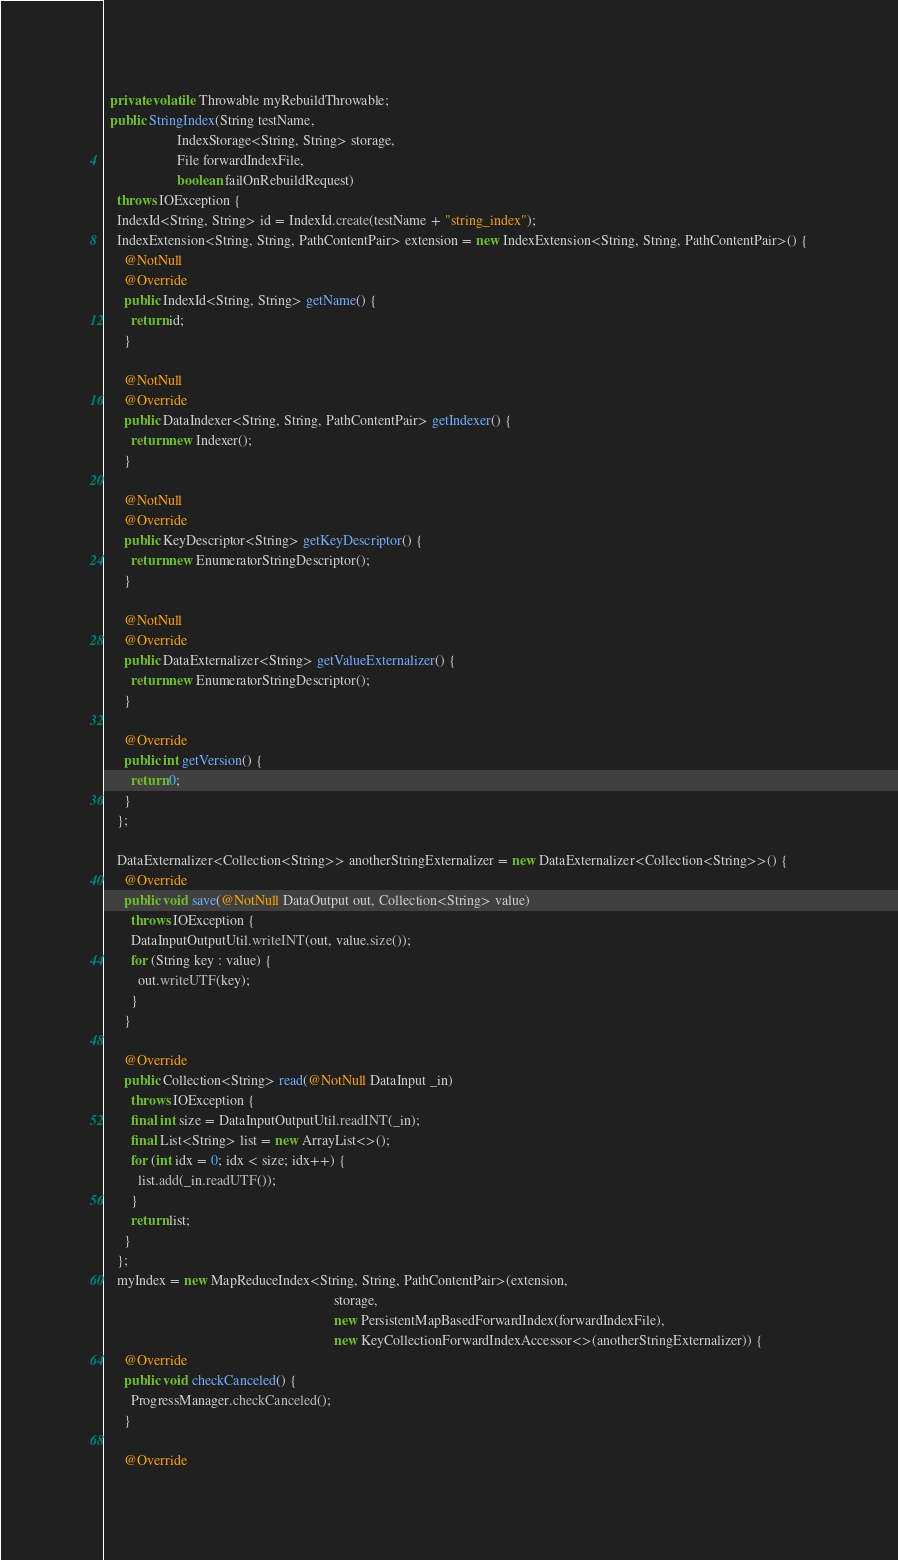<code> <loc_0><loc_0><loc_500><loc_500><_Java_>  private volatile Throwable myRebuildThrowable;
  public StringIndex(String testName,
                     IndexStorage<String, String> storage,
                     File forwardIndexFile,
                     boolean failOnRebuildRequest)
    throws IOException {
    IndexId<String, String> id = IndexId.create(testName + "string_index");
    IndexExtension<String, String, PathContentPair> extension = new IndexExtension<String, String, PathContentPair>() {
      @NotNull
      @Override
      public IndexId<String, String> getName() {
        return id;
      }

      @NotNull
      @Override
      public DataIndexer<String, String, PathContentPair> getIndexer() {
        return new Indexer();
      }

      @NotNull
      @Override
      public KeyDescriptor<String> getKeyDescriptor() {
        return new EnumeratorStringDescriptor();
      }

      @NotNull
      @Override
      public DataExternalizer<String> getValueExternalizer() {
        return new EnumeratorStringDescriptor();
      }

      @Override
      public int getVersion() {
        return 0;
      }
    };

    DataExternalizer<Collection<String>> anotherStringExternalizer = new DataExternalizer<Collection<String>>() {
      @Override
      public void save(@NotNull DataOutput out, Collection<String> value)
        throws IOException {
        DataInputOutputUtil.writeINT(out, value.size());
        for (String key : value) {
          out.writeUTF(key);
        }
      }

      @Override
      public Collection<String> read(@NotNull DataInput _in)
        throws IOException {
        final int size = DataInputOutputUtil.readINT(_in);
        final List<String> list = new ArrayList<>();
        for (int idx = 0; idx < size; idx++) {
          list.add(_in.readUTF());
        }
        return list;
      }
    };
    myIndex = new MapReduceIndex<String, String, PathContentPair>(extension,
                                                                  storage,
                                                                  new PersistentMapBasedForwardIndex(forwardIndexFile),
                                                                  new KeyCollectionForwardIndexAccessor<>(anotherStringExternalizer)) {
      @Override
      public void checkCanceled() {
        ProgressManager.checkCanceled();
      }

      @Override</code> 